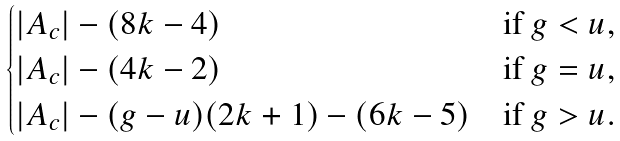<formula> <loc_0><loc_0><loc_500><loc_500>\begin{cases} | A _ { c } | - ( 8 k - 4 ) & \text {if $g < u$,} \\ | A _ { c } | - ( 4 k - 2 ) & \text {if $g = u$,} \\ | A _ { c } | - ( g - u ) ( 2 k + 1 ) - ( 6 k - 5 ) & \text {if $g > u$.} \end{cases}</formula> 